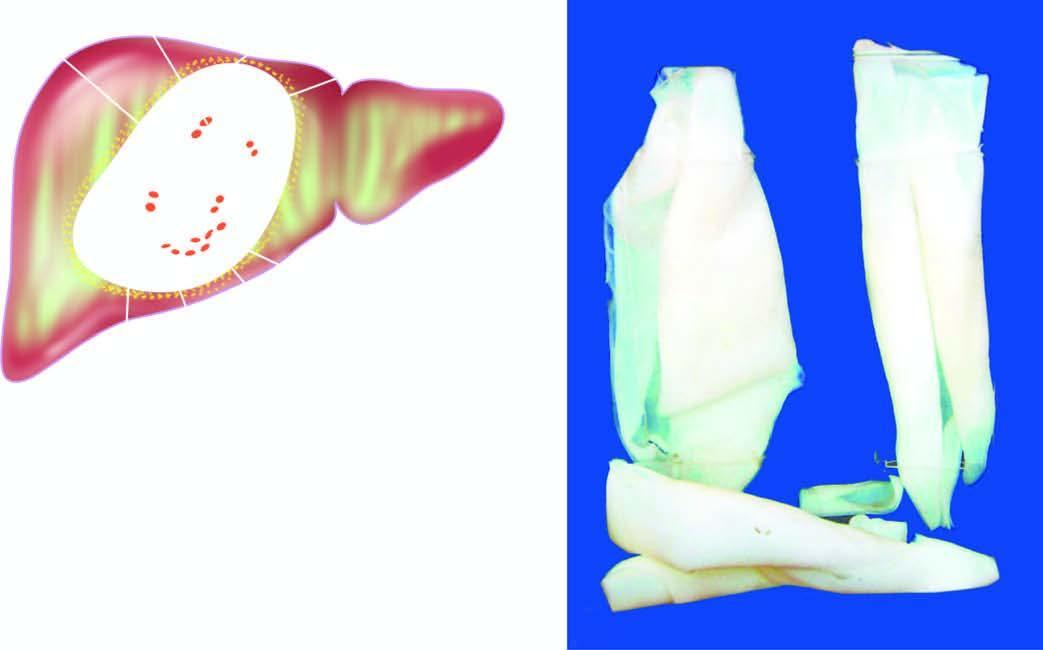what is the cyst wall composed of?
Answer the question using a single word or phrase. Whitish membrane resembling the membrane of a hard boiled egg 